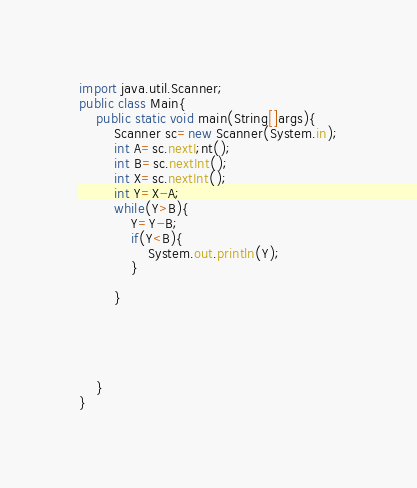<code> <loc_0><loc_0><loc_500><loc_500><_Java_>import java.util.Scanner;
public class Main{
    public static void main(String[]args){
        Scanner sc=new Scanner(System.in);
        int A=sc.nextI;nt();
        int B=sc.nextInt();
        int X=sc.nextInt();
        int Y=X-A;
        while(Y>B){
            Y=Y-B;
            if(Y<B){
                System.out.println(Y);
            }
          
        }
        

        


    }
}
</code> 